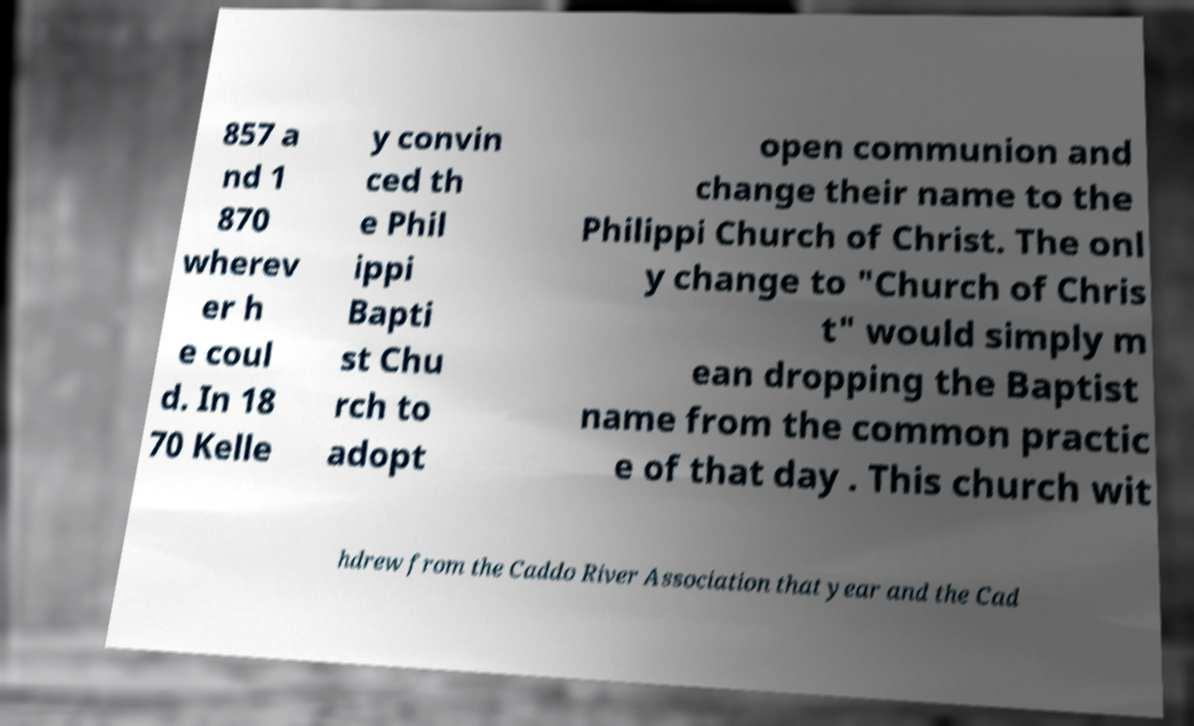What messages or text are displayed in this image? I need them in a readable, typed format. 857 a nd 1 870 wherev er h e coul d. In 18 70 Kelle y convin ced th e Phil ippi Bapti st Chu rch to adopt open communion and change their name to the Philippi Church of Christ. The onl y change to "Church of Chris t" would simply m ean dropping the Baptist name from the common practic e of that day . This church wit hdrew from the Caddo River Association that year and the Cad 